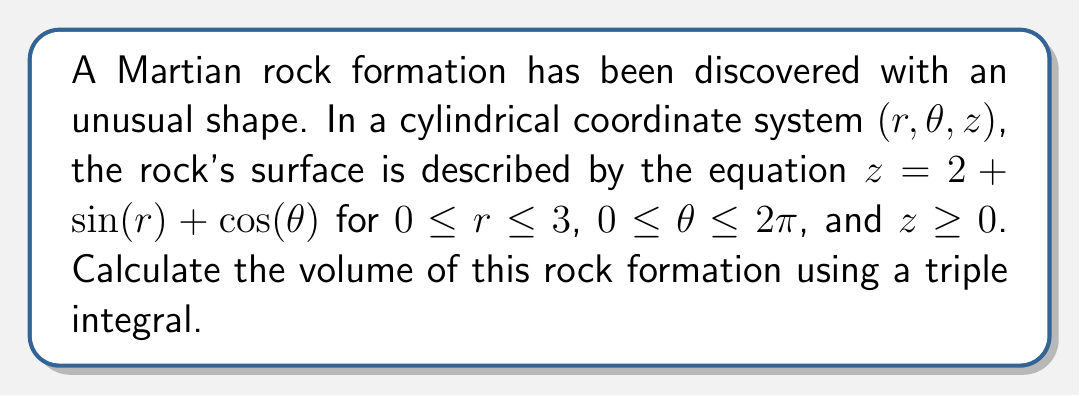Show me your answer to this math problem. To calculate the volume of this irregular Martian rock formation, we need to set up and evaluate a triple integral in cylindrical coordinates. The steps are as follows:

1) The volume is given by the integral:

   $$V = \iiint_D dV = \int_0^{2\pi} \int_0^3 \int_0^{2+\sin(r)+\cos(\theta)} r \, dz \, dr \, d\theta$$

2) Let's evaluate the innermost integral first:

   $$\int_0^{2+\sin(r)+\cos(\theta)} dz = [z]_0^{2+\sin(r)+\cos(\theta)} = 2+\sin(r)+\cos(\theta)$$

3) Now our integral becomes:

   $$V = \int_0^{2\pi} \int_0^3 r(2+\sin(r)+\cos(\theta)) \, dr \, d\theta$$

4) Let's expand this:

   $$V = \int_0^{2\pi} \int_0^3 (2r + r\sin(r) + r\cos(\theta)) \, dr \, d\theta$$

5) Now we can evaluate the inner integral with respect to $r$:

   $$\int_0^3 2r \, dr = [r^2]_0^3 = 9$$
   
   $$\int_0^3 r\sin(r) \, dr = [-r\cos(r)]_0^3 + \int_0^3 \cos(r) \, dr = -3\cos(3) + \sin(3)$$
   
   $$\int_0^3 r\cos(\theta) \, dr = \frac{1}{2}r^2\cos(\theta)]_0^3 = \frac{9}{2}\cos(\theta)$$

6) Substituting these back:

   $$V = \int_0^{2\pi} (9 - 3\cos(3) + \sin(3) + \frac{9}{2}\cos(\theta)) \, d\theta$$

7) Now we can evaluate the final integral:

   $$9 \int_0^{2\pi} d\theta = 18\pi$$
   
   $$(-3\cos(3) + \sin(3)) \int_0^{2\pi} d\theta = 2\pi(-3\cos(3) + \sin(3))$$
   
   $$\frac{9}{2} \int_0^{2\pi} \cos(\theta) \, d\theta = 0$$

8) Adding these together:

   $$V = 18\pi + 2\pi(-3\cos(3) + \sin(3))$$

9) Simplifying:

   $$V = 2\pi(9 - 3\cos(3) + \sin(3))$$

This is the exact volume of the Martian rock formation.
Answer: The volume of the Martian rock formation is $2\pi(9 - 3\cos(3) + \sin(3))$ cubic units. 